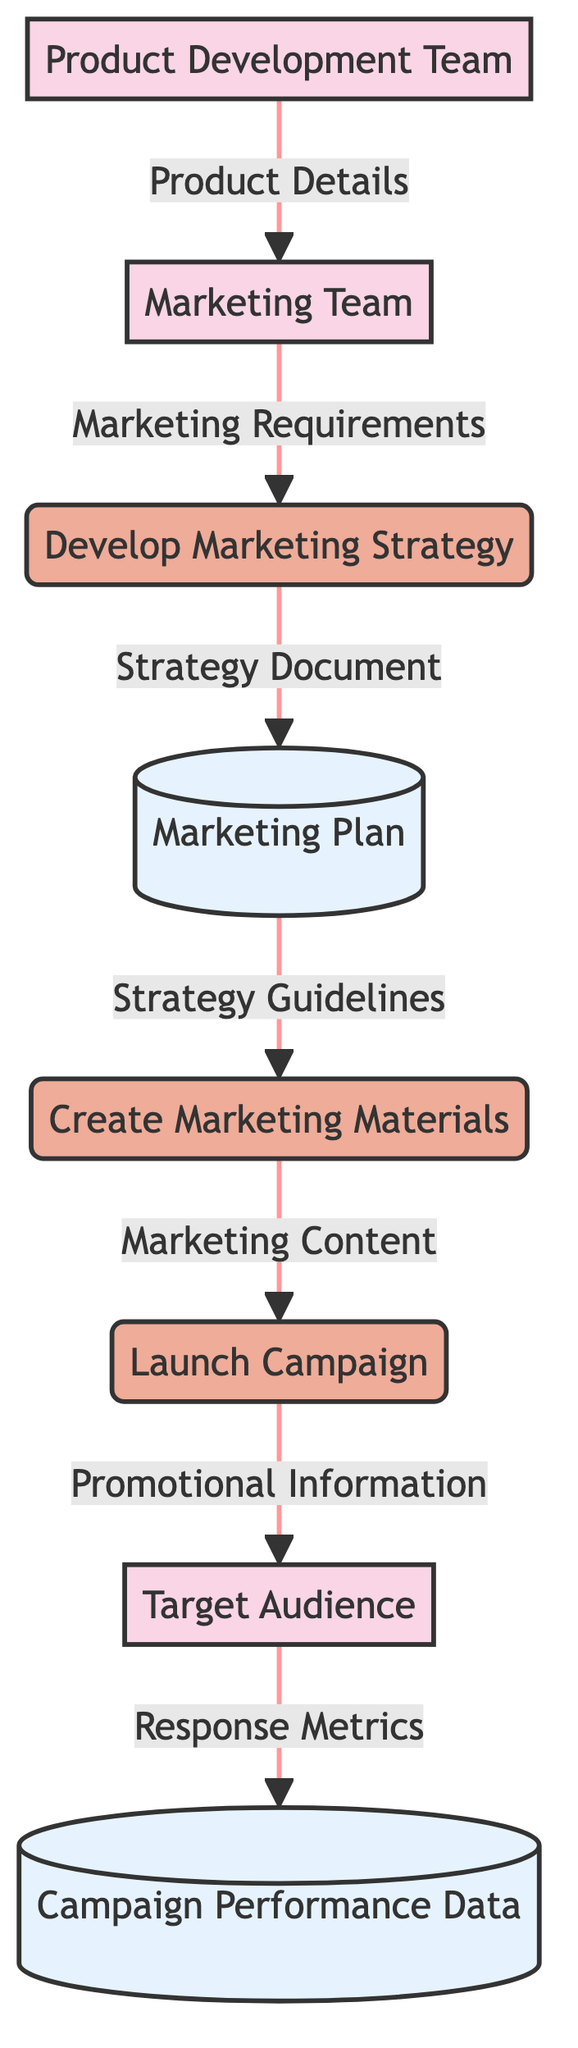What is the first external entity in the diagram? The external entities in the diagram are listed in order, with the Marketing Team appearing first.
Answer: Marketing Team How many processes are represented in this diagram? The diagram includes three processes: Develop Marketing Strategy, Create Marketing Materials, and Launch Campaign, which sums up to three processes.
Answer: 3 What type of data is sent from the Product Development Team to the Marketing Team? The connection from the Product Development Team to the Marketing Team indicates that Product Details, which describe information about the features and benefits of the new product, is sent.
Answer: Product Details Which data store contains information about campaign effectiveness? The Campaign Performance Data data store is specifically indicated to contain data regarding audience engagement and campaign effectiveness.
Answer: Campaign Performance Data What is the final output from the Launch Campaign process? The final output from Launch Campaign is the Promotional Information delivered to the Target Audience, showcasing the promotional messages of the campaign.
Answer: Promotional Information What does the Develop Marketing Strategy process receive from the Marketing Team? The Develop Marketing Strategy process receives Marketing Requirements from the Marketing Team, detailing the campaign goals and target market.
Answer: Marketing Requirements How does the Marketing Plan interact with the Create Marketing Materials process? The Marketing Plan provides Strategy Guidelines to the Create Marketing Materials process, guiding the development of specific marketing content.
Answer: Strategy Guidelines Which external entity is the end recipient of the promotional information? The Target Audience is the external entity that ultimately receives the promotional information as the campaign messages.
Answer: Target Audience What information is flowing from the Target Audience to the Campaign Performance Data? The Response Metrics are sent from the Target Audience to the Campaign Performance Data, tracking data on audience engagement and campaign effectiveness.
Answer: Response Metrics 